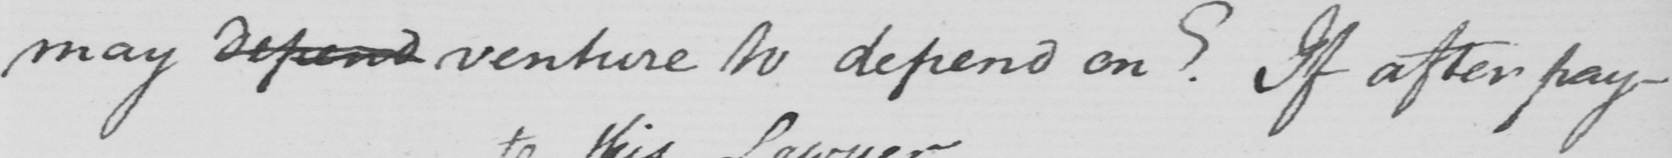What text is written in this handwritten line? may depend venture to depend on? If after pay- 